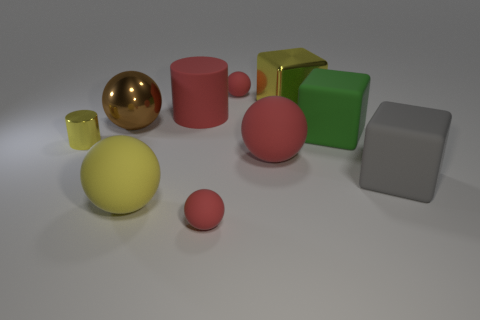What number of other things are there of the same material as the big cylinder There are six objects in the image that appear to be made of the same matte material as the large pink cylinder. These include two small cylinders, two spheres, and two cubes. 